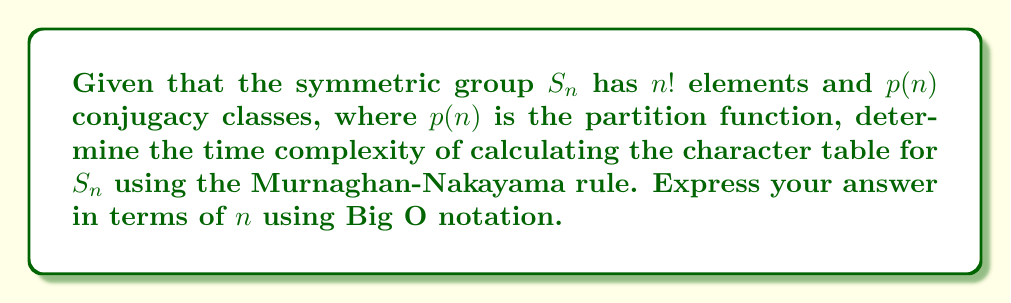Give your solution to this math problem. To determine the time complexity, let's break down the process:

1. The character table for $S_n$ is a $p(n) \times p(n)$ matrix, where $p(n)$ is the number of partitions of $n$.

2. For each entry in the character table, we need to apply the Murnaghan-Nakayama rule, which involves calculating the number of rim hook tableaux.

3. The Murnaghan-Nakayama rule has a recursive nature, and its complexity depends on the number of ways to remove rim hooks from the Young diagram.

4. In the worst case, for each character calculation, we might need to consider all possible ways of removing rim hooks, which is bounded by $2^n$.

5. We need to perform this calculation for each entry in the $p(n) \times p(n)$ character table.

6. The partition function $p(n)$ grows asymptotically as:

   $$p(n) \sim \frac{1}{4n\sqrt{3}} e^{\pi \sqrt{2n/3}}$$

7. Therefore, the total time complexity is bounded by:

   $$O(p(n)^2 \cdot 2^n) \approx O\left(\left(\frac{1}{4n\sqrt{3}} e^{\pi \sqrt{2n/3}}\right)^2 \cdot 2^n\right)$$

8. Simplifying and focusing on the dominant terms:

   $$O\left(e^{2\pi \sqrt{2n/3}} \cdot 2^n\right)$$

This expression represents the upper bound of the time complexity for calculating the character table of $S_n$ using the Murnaghan-Nakayama rule.
Answer: $O\left(e^{2\pi \sqrt{2n/3}} \cdot 2^n\right)$ 